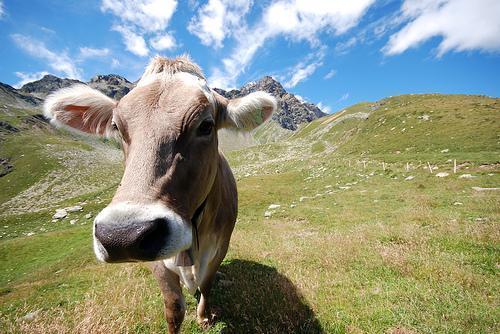How many cows are there?
Give a very brief answer. 1. 